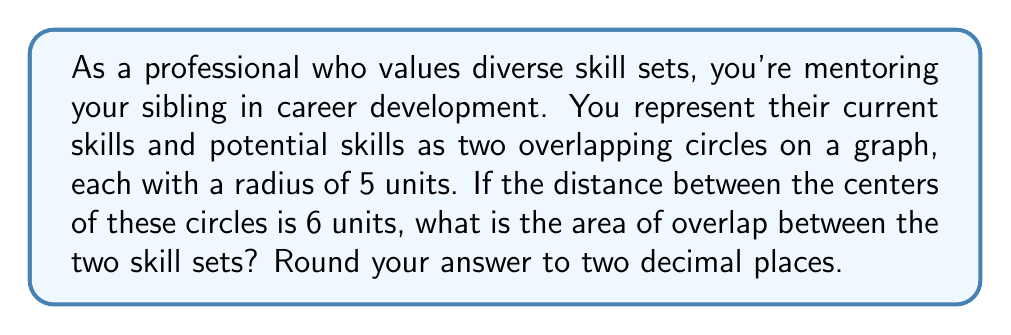Provide a solution to this math problem. Let's approach this step-by-step:

1) We have two circles with equal radii $r = 5$ units, and the distance between their centers is $d = 6$ units.

2) The area of overlap between two circles is given by the formula:

   $$A = 2r^2 \arccos(\frac{d}{2r}) - d\sqrt{r^2 - (\frac{d}{2})^2}$$

3) Let's substitute our values:

   $$A = 2(5^2) \arccos(\frac{6}{2(5)}) - 6\sqrt{5^2 - (\frac{6}{2})^2}$$

4) Simplify inside the arccos and under the square root:

   $$A = 50 \arccos(\frac{3}{5}) - 6\sqrt{25 - 9}$$

5) Simplify further:

   $$A = 50 \arccos(0.6) - 6\sqrt{16}$$

6) Calculate:
   
   $$A = 50(0.9273) - 6(4) = 46.365 - 24 = 22.365$$

7) Rounding to two decimal places:

   $$A \approx 22.37$$

[asy]
unitsize(10mm);
pair A = (0,0), B = (6,0);
draw(circle(A,5));
draw(circle(B,5));
label("A", A, SW);
label("B", B, SE);
draw(A--B, dashed);
label("6", (A+B)/2, S);
[/asy]
Answer: 22.37 square units 